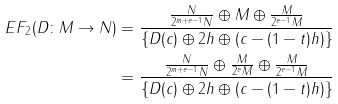<formula> <loc_0><loc_0><loc_500><loc_500>E F _ { 2 } ( D \colon M \to N ) & = \frac { \frac { N } { 2 ^ { m + e - 1 } N } \oplus M \oplus \frac { M } { 2 ^ { e - 1 } M } } { \{ D ( c ) \oplus 2 h \oplus ( c - ( 1 - t ) h ) \} } \\ & = \frac { \frac { N } { 2 ^ { m + e - 1 } N } \oplus \frac { M } { 2 ^ { e } M } \oplus \frac { M } { 2 ^ { e - 1 } M } } { \{ D ( c ) \oplus 2 h \oplus ( c - ( 1 - t ) h ) \} } \\</formula> 